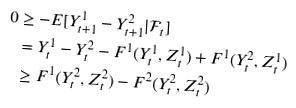Convert formula to latex. <formula><loc_0><loc_0><loc_500><loc_500>0 & \geq - E [ Y ^ { 1 } _ { t + 1 } - Y ^ { 2 } _ { t + 1 } | \mathcal { F } _ { t } ] \\ & = Y ^ { 1 } _ { t } - Y ^ { 2 } _ { t } - F ^ { 1 } ( Y _ { t } ^ { 1 } , Z _ { t } ^ { 1 } ) + F ^ { 1 } ( Y _ { t } ^ { 2 } , Z _ { t } ^ { 1 } ) \\ & \geq F ^ { 1 } ( Y _ { t } ^ { 2 } , Z _ { t } ^ { 2 } ) - F ^ { 2 } ( Y _ { t } ^ { 2 } , Z _ { t } ^ { 2 } )</formula> 